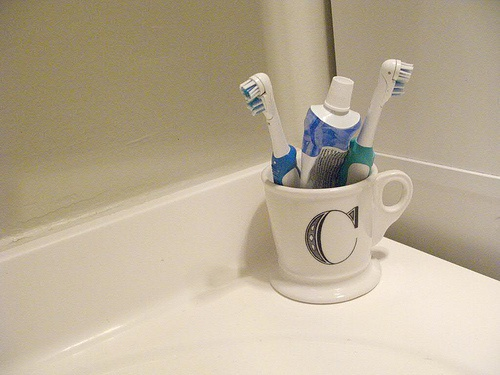Describe the objects in this image and their specific colors. I can see cup in gray, tan, and lightgray tones, toothbrush in gray, darkgray, tan, and teal tones, and toothbrush in gray, darkgray, tan, and blue tones in this image. 